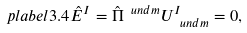Convert formula to latex. <formula><loc_0><loc_0><loc_500><loc_500>\ p l a b e l { 3 . 4 } \hat { E } ^ { I } = \hat { \Pi } ^ { \ u n d { m } } U _ { \ u n d { m } } ^ { I } = 0 ,</formula> 